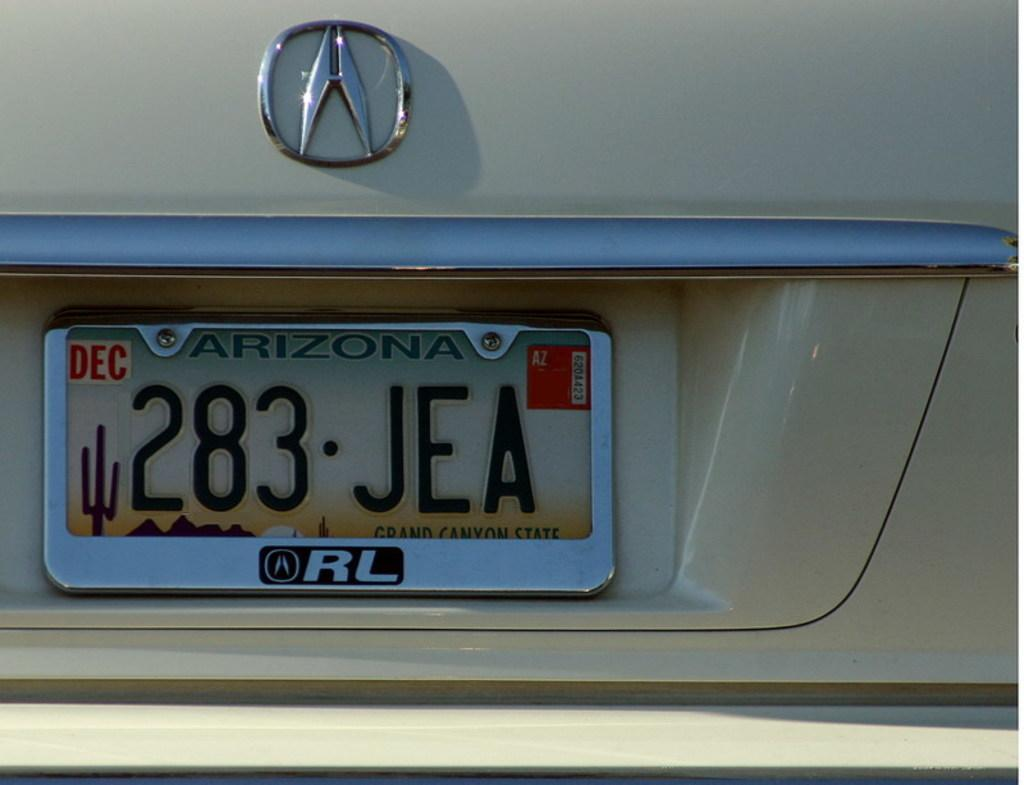<image>
Describe the image concisely. The Arizona license plate read 283 JEA  on a tan vehicle 